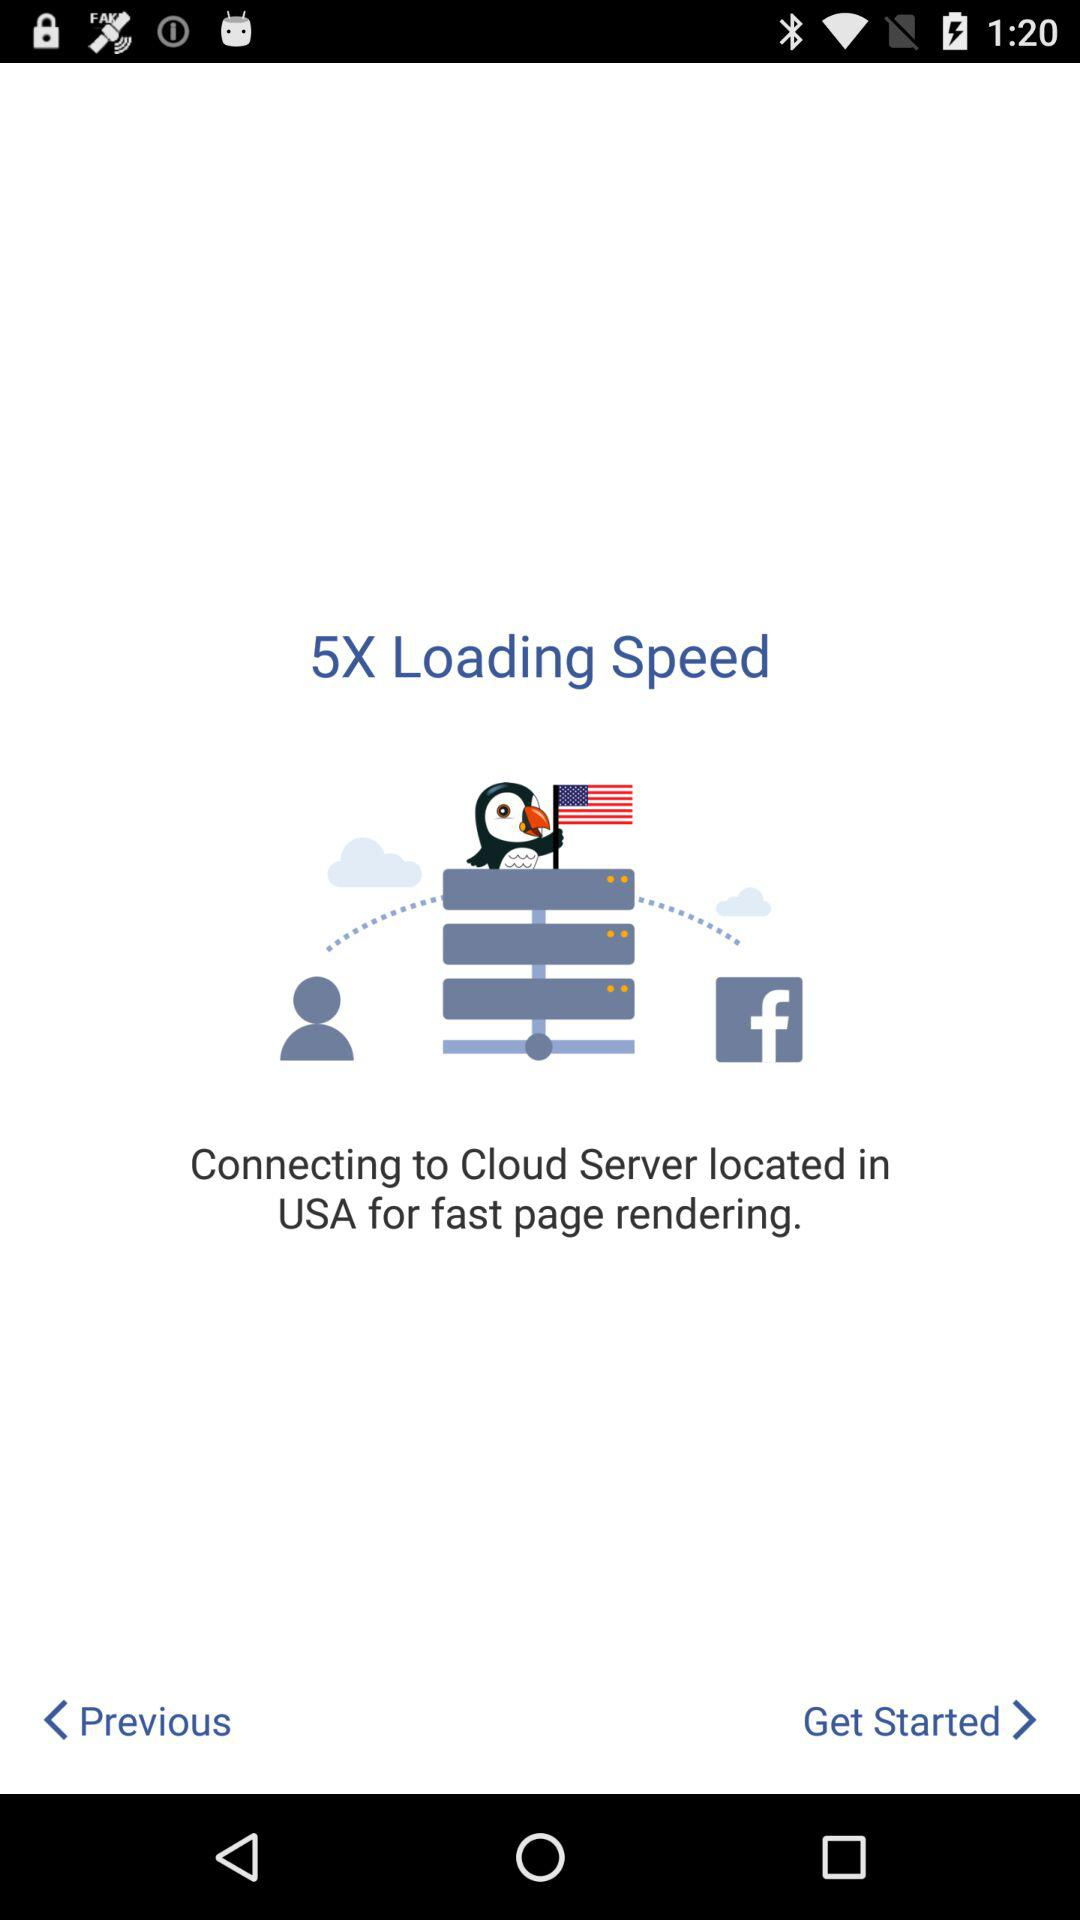What is the mentioned location? The mentioned location is the USA. 